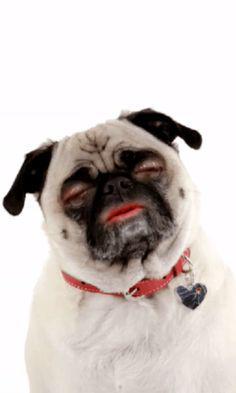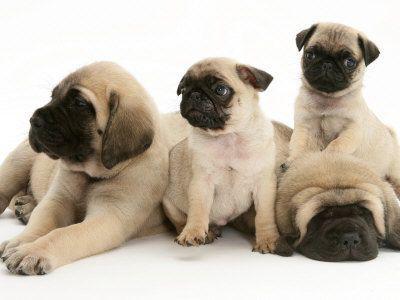The first image is the image on the left, the second image is the image on the right. Evaluate the accuracy of this statement regarding the images: "There are three or fewer dogs in total.". Is it true? Answer yes or no. No. The first image is the image on the left, the second image is the image on the right. Evaluate the accuracy of this statement regarding the images: "The right image contains at least two dogs.". Is it true? Answer yes or no. Yes. 